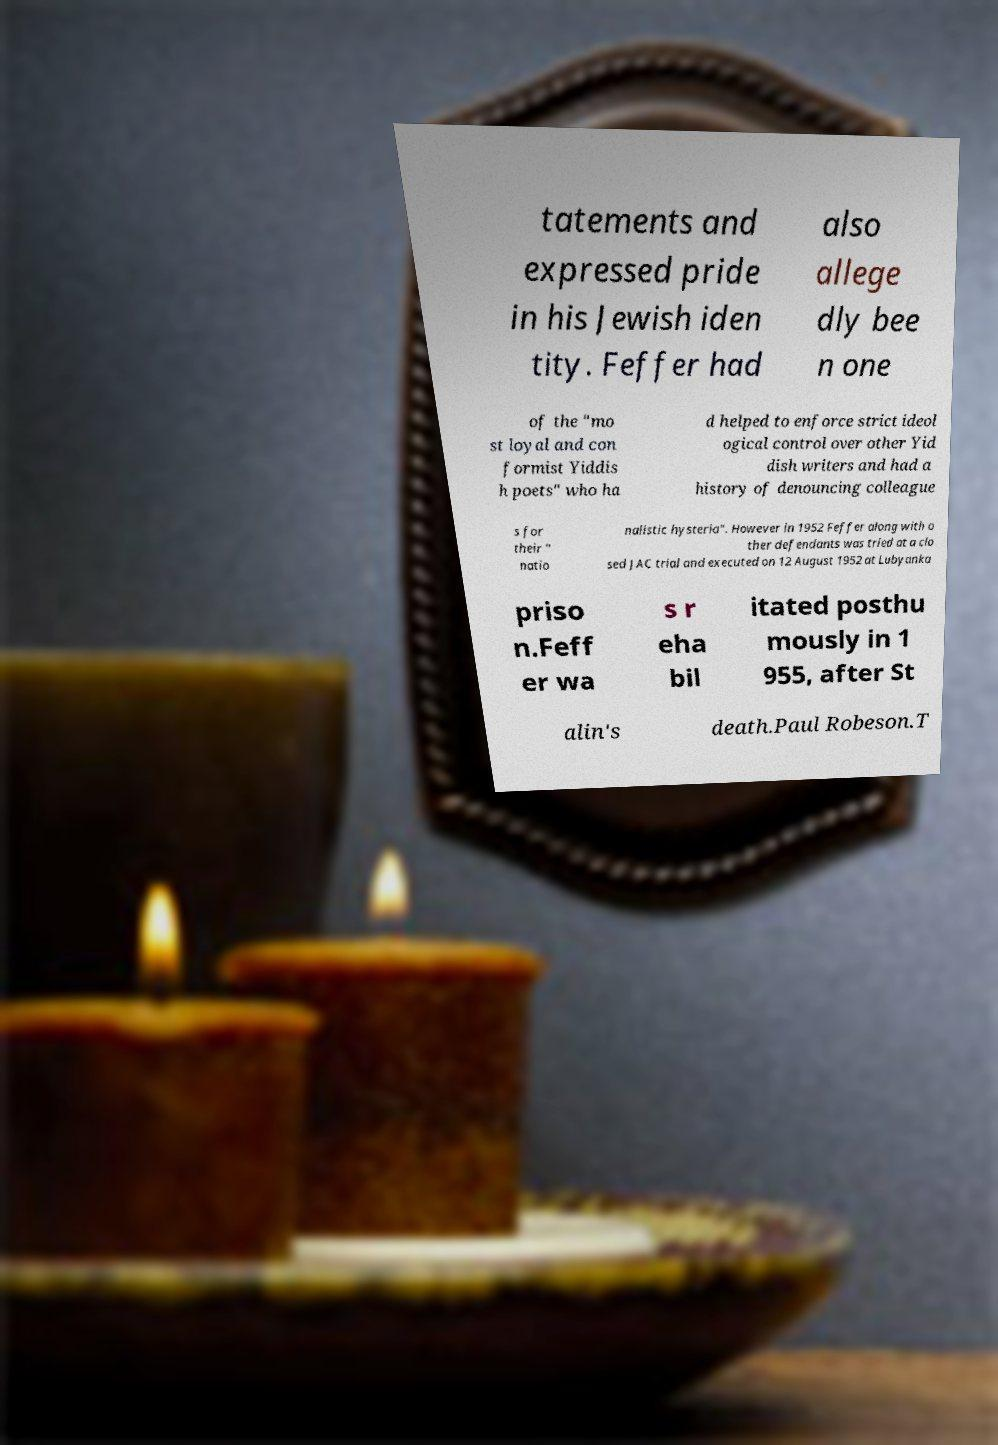What messages or text are displayed in this image? I need them in a readable, typed format. tatements and expressed pride in his Jewish iden tity. Feffer had also allege dly bee n one of the "mo st loyal and con formist Yiddis h poets" who ha d helped to enforce strict ideol ogical control over other Yid dish writers and had a history of denouncing colleague s for their " natio nalistic hysteria". However in 1952 Feffer along with o ther defendants was tried at a clo sed JAC trial and executed on 12 August 1952 at Lubyanka priso n.Feff er wa s r eha bil itated posthu mously in 1 955, after St alin's death.Paul Robeson.T 